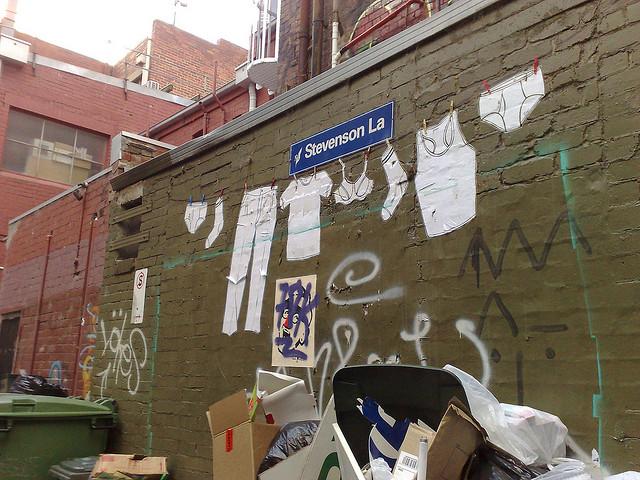Is all the trash in boxes?
Give a very brief answer. No. Is the paint still wet?
Quick response, please. No. Was this picture taken outside?
Give a very brief answer. Yes. Who more than wrote the writings on the wall?
Short answer required. I don't know. What is painted on the wall under the sign?
Keep it brief. Clothes. Do you see lots of garbage?
Write a very short answer. Yes. Is the graffiti excessive on this wall?
Short answer required. Yes. 